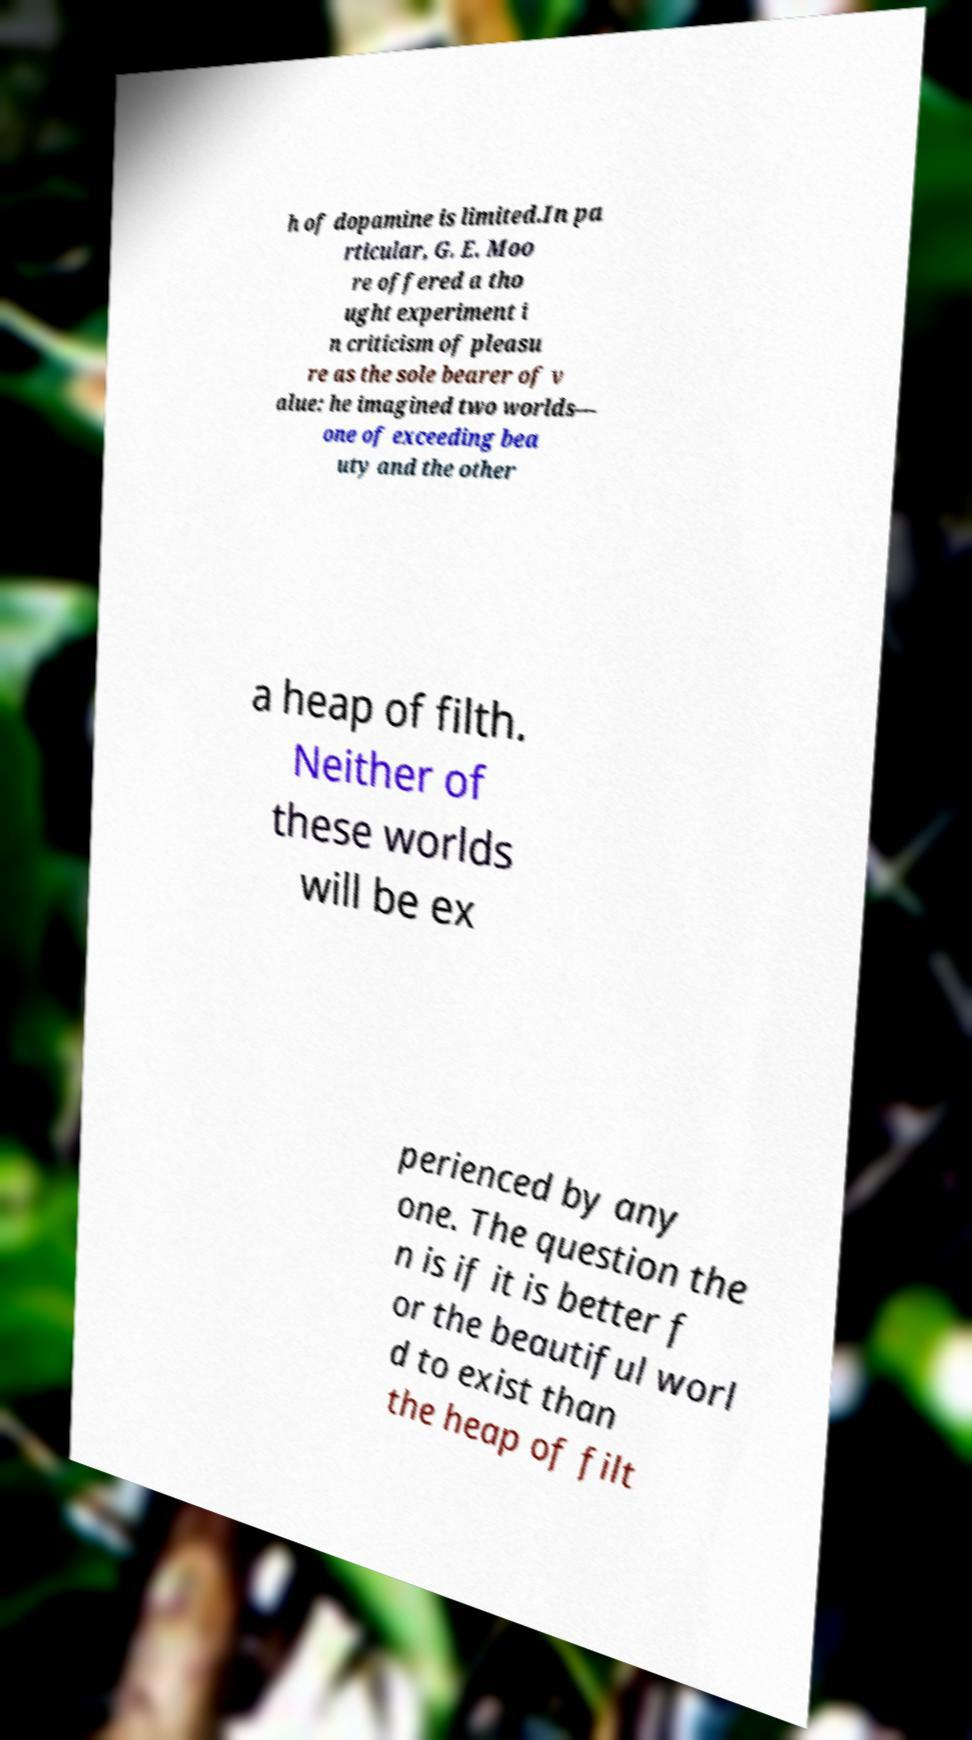Please identify and transcribe the text found in this image. h of dopamine is limited.In pa rticular, G. E. Moo re offered a tho ught experiment i n criticism of pleasu re as the sole bearer of v alue: he imagined two worlds— one of exceeding bea uty and the other a heap of filth. Neither of these worlds will be ex perienced by any one. The question the n is if it is better f or the beautiful worl d to exist than the heap of filt 